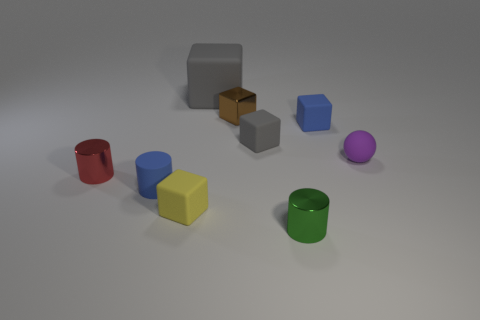There is a tiny matte block behind the tiny gray cube; does it have the same color as the small rubber cylinder?
Your response must be concise. Yes. What is the size of the gray matte block left of the metal block?
Provide a succinct answer. Large. Are there more tiny blocks that are on the left side of the green metal thing than large yellow metal things?
Provide a succinct answer. Yes. What is the shape of the green shiny object?
Ensure brevity in your answer.  Cylinder. Is the color of the matte cylinder in front of the large cube the same as the cube to the right of the green metal object?
Give a very brief answer. Yes. Does the small green metallic object have the same shape as the red object?
Your response must be concise. Yes. Is there anything else that is the same shape as the tiny purple matte thing?
Keep it short and to the point. No. Do the cylinder to the right of the brown thing and the red cylinder have the same material?
Your response must be concise. Yes. What shape is the small matte object that is both left of the tiny sphere and on the right side of the tiny green metallic object?
Your answer should be compact. Cube. Is there a small object on the right side of the tiny metal cylinder that is to the left of the small green cylinder?
Keep it short and to the point. Yes. 